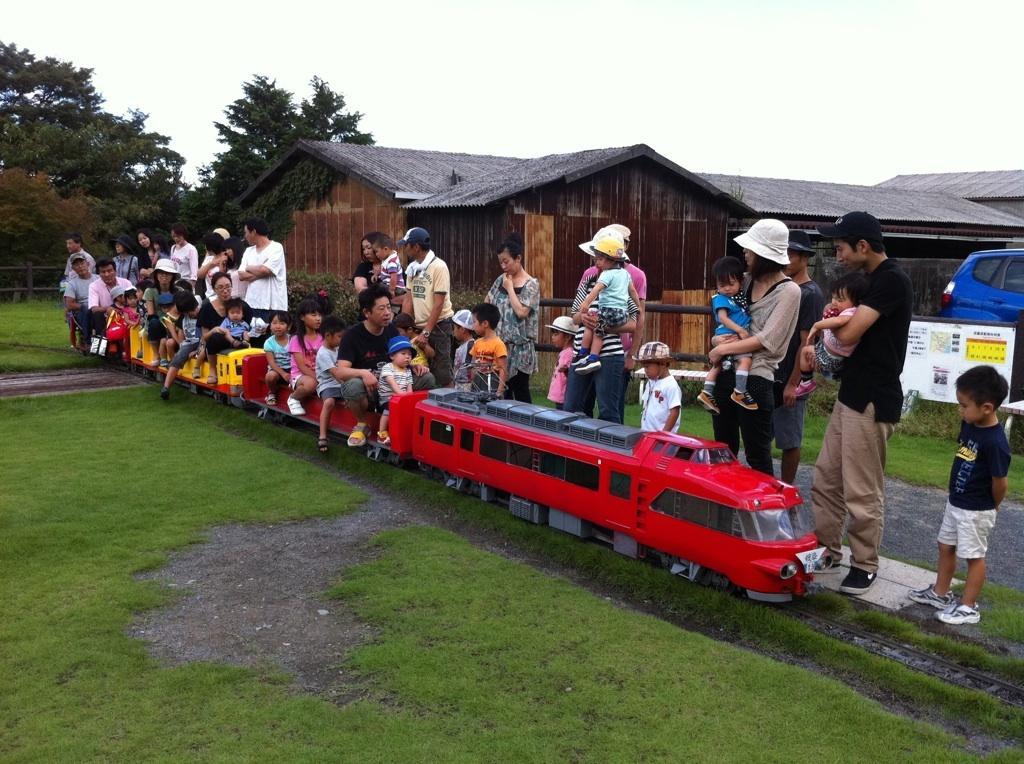Describe this image in one or two sentences. In this image I can see group of people some are sitting on the train and some are standing. The train is in red and yellow color, at back I can see houses in brown color, trees in green color and sky in white color. 